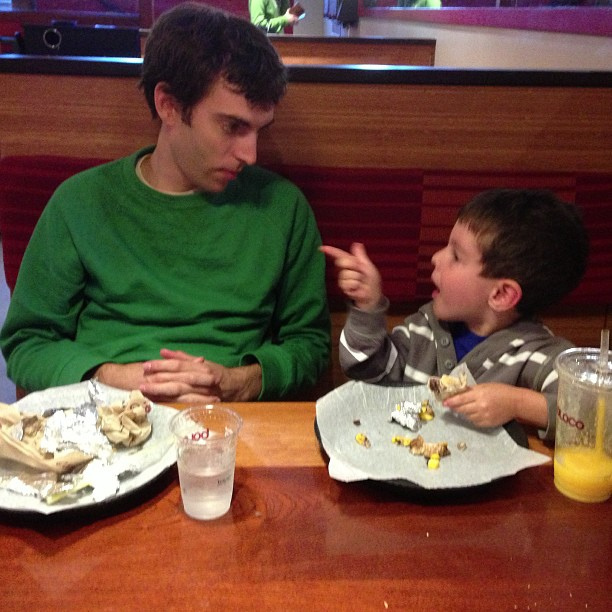Identify and read out the text in this image. LOCO 